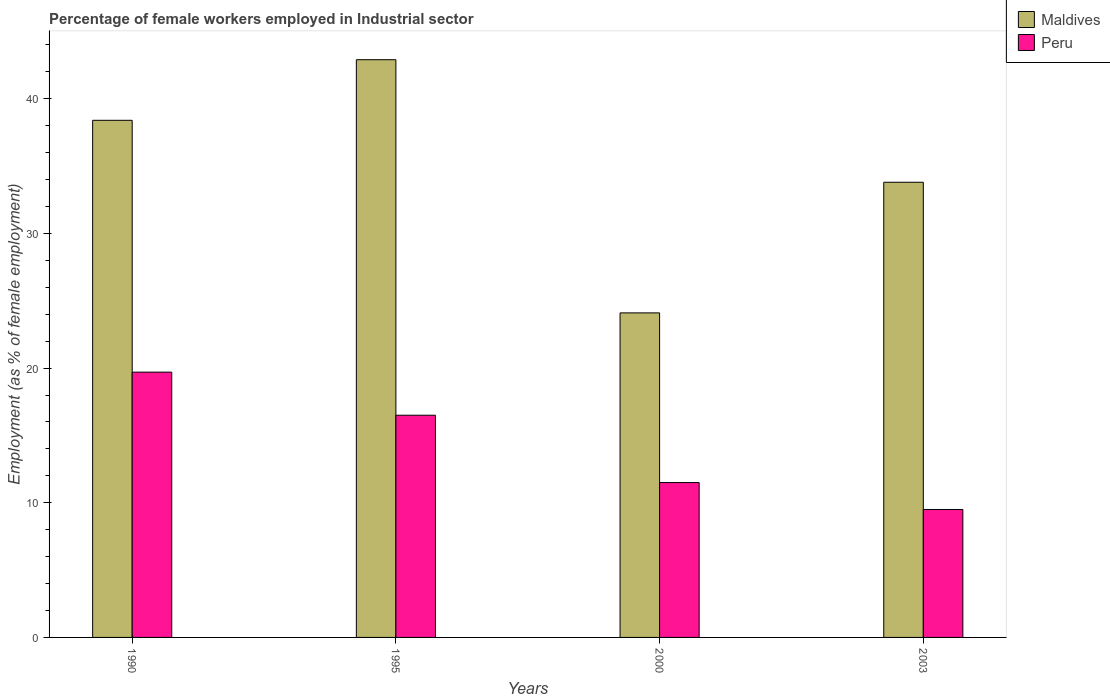How many groups of bars are there?
Your answer should be compact. 4. What is the label of the 4th group of bars from the left?
Make the answer very short. 2003. What is the percentage of females employed in Industrial sector in Peru in 1990?
Your answer should be very brief. 19.7. Across all years, what is the maximum percentage of females employed in Industrial sector in Peru?
Provide a short and direct response. 19.7. Across all years, what is the minimum percentage of females employed in Industrial sector in Peru?
Offer a terse response. 9.5. In which year was the percentage of females employed in Industrial sector in Peru maximum?
Ensure brevity in your answer.  1990. What is the total percentage of females employed in Industrial sector in Maldives in the graph?
Provide a short and direct response. 139.2. What is the difference between the percentage of females employed in Industrial sector in Maldives in 1990 and that in 2000?
Offer a terse response. 14.3. What is the difference between the percentage of females employed in Industrial sector in Peru in 2003 and the percentage of females employed in Industrial sector in Maldives in 1995?
Your answer should be very brief. -33.4. What is the average percentage of females employed in Industrial sector in Peru per year?
Provide a succinct answer. 14.3. In the year 1995, what is the difference between the percentage of females employed in Industrial sector in Maldives and percentage of females employed in Industrial sector in Peru?
Give a very brief answer. 26.4. What is the ratio of the percentage of females employed in Industrial sector in Peru in 1990 to that in 1995?
Make the answer very short. 1.19. What is the difference between the highest and the second highest percentage of females employed in Industrial sector in Peru?
Provide a short and direct response. 3.2. What is the difference between the highest and the lowest percentage of females employed in Industrial sector in Maldives?
Your response must be concise. 18.8. Is the sum of the percentage of females employed in Industrial sector in Peru in 1990 and 2003 greater than the maximum percentage of females employed in Industrial sector in Maldives across all years?
Offer a terse response. No. What does the 1st bar from the left in 1990 represents?
Make the answer very short. Maldives. What does the 1st bar from the right in 2003 represents?
Provide a short and direct response. Peru. How many bars are there?
Give a very brief answer. 8. Are the values on the major ticks of Y-axis written in scientific E-notation?
Your answer should be very brief. No. How are the legend labels stacked?
Your response must be concise. Vertical. What is the title of the graph?
Provide a succinct answer. Percentage of female workers employed in Industrial sector. What is the label or title of the Y-axis?
Your answer should be compact. Employment (as % of female employment). What is the Employment (as % of female employment) in Maldives in 1990?
Your answer should be very brief. 38.4. What is the Employment (as % of female employment) in Peru in 1990?
Ensure brevity in your answer.  19.7. What is the Employment (as % of female employment) of Maldives in 1995?
Your answer should be compact. 42.9. What is the Employment (as % of female employment) of Maldives in 2000?
Provide a short and direct response. 24.1. What is the Employment (as % of female employment) of Maldives in 2003?
Offer a terse response. 33.8. Across all years, what is the maximum Employment (as % of female employment) in Maldives?
Keep it short and to the point. 42.9. Across all years, what is the maximum Employment (as % of female employment) of Peru?
Offer a very short reply. 19.7. Across all years, what is the minimum Employment (as % of female employment) in Maldives?
Offer a terse response. 24.1. What is the total Employment (as % of female employment) in Maldives in the graph?
Offer a very short reply. 139.2. What is the total Employment (as % of female employment) in Peru in the graph?
Offer a very short reply. 57.2. What is the difference between the Employment (as % of female employment) of Peru in 1990 and that in 1995?
Provide a short and direct response. 3.2. What is the difference between the Employment (as % of female employment) in Peru in 1990 and that in 2000?
Make the answer very short. 8.2. What is the difference between the Employment (as % of female employment) of Maldives in 1990 and that in 2003?
Provide a succinct answer. 4.6. What is the difference between the Employment (as % of female employment) in Peru in 1990 and that in 2003?
Ensure brevity in your answer.  10.2. What is the difference between the Employment (as % of female employment) of Peru in 2000 and that in 2003?
Keep it short and to the point. 2. What is the difference between the Employment (as % of female employment) of Maldives in 1990 and the Employment (as % of female employment) of Peru in 1995?
Make the answer very short. 21.9. What is the difference between the Employment (as % of female employment) of Maldives in 1990 and the Employment (as % of female employment) of Peru in 2000?
Offer a terse response. 26.9. What is the difference between the Employment (as % of female employment) of Maldives in 1990 and the Employment (as % of female employment) of Peru in 2003?
Your response must be concise. 28.9. What is the difference between the Employment (as % of female employment) of Maldives in 1995 and the Employment (as % of female employment) of Peru in 2000?
Provide a succinct answer. 31.4. What is the difference between the Employment (as % of female employment) in Maldives in 1995 and the Employment (as % of female employment) in Peru in 2003?
Make the answer very short. 33.4. What is the difference between the Employment (as % of female employment) of Maldives in 2000 and the Employment (as % of female employment) of Peru in 2003?
Your answer should be compact. 14.6. What is the average Employment (as % of female employment) in Maldives per year?
Your response must be concise. 34.8. In the year 1995, what is the difference between the Employment (as % of female employment) of Maldives and Employment (as % of female employment) of Peru?
Your answer should be compact. 26.4. In the year 2003, what is the difference between the Employment (as % of female employment) of Maldives and Employment (as % of female employment) of Peru?
Offer a terse response. 24.3. What is the ratio of the Employment (as % of female employment) in Maldives in 1990 to that in 1995?
Your response must be concise. 0.9. What is the ratio of the Employment (as % of female employment) of Peru in 1990 to that in 1995?
Your answer should be very brief. 1.19. What is the ratio of the Employment (as % of female employment) in Maldives in 1990 to that in 2000?
Make the answer very short. 1.59. What is the ratio of the Employment (as % of female employment) in Peru in 1990 to that in 2000?
Offer a terse response. 1.71. What is the ratio of the Employment (as % of female employment) in Maldives in 1990 to that in 2003?
Ensure brevity in your answer.  1.14. What is the ratio of the Employment (as % of female employment) in Peru in 1990 to that in 2003?
Keep it short and to the point. 2.07. What is the ratio of the Employment (as % of female employment) of Maldives in 1995 to that in 2000?
Your answer should be compact. 1.78. What is the ratio of the Employment (as % of female employment) of Peru in 1995 to that in 2000?
Give a very brief answer. 1.43. What is the ratio of the Employment (as % of female employment) in Maldives in 1995 to that in 2003?
Your answer should be compact. 1.27. What is the ratio of the Employment (as % of female employment) in Peru in 1995 to that in 2003?
Ensure brevity in your answer.  1.74. What is the ratio of the Employment (as % of female employment) of Maldives in 2000 to that in 2003?
Make the answer very short. 0.71. What is the ratio of the Employment (as % of female employment) in Peru in 2000 to that in 2003?
Provide a short and direct response. 1.21. What is the difference between the highest and the lowest Employment (as % of female employment) of Maldives?
Make the answer very short. 18.8. What is the difference between the highest and the lowest Employment (as % of female employment) of Peru?
Your answer should be very brief. 10.2. 